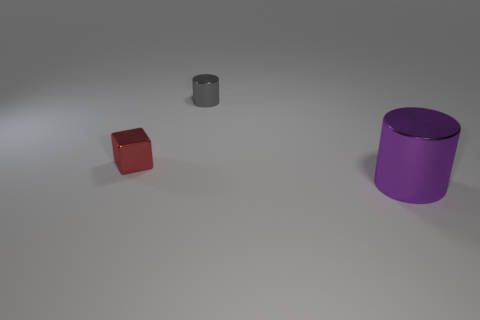Add 3 tiny red matte objects. How many objects exist? 6 Subtract all tiny gray cylinders. Subtract all big purple shiny objects. How many objects are left? 1 Add 1 big purple metallic objects. How many big purple metallic objects are left? 2 Add 3 tiny gray cylinders. How many tiny gray cylinders exist? 4 Subtract 0 gray spheres. How many objects are left? 3 Subtract all cylinders. How many objects are left? 1 Subtract all brown cubes. Subtract all gray cylinders. How many cubes are left? 1 